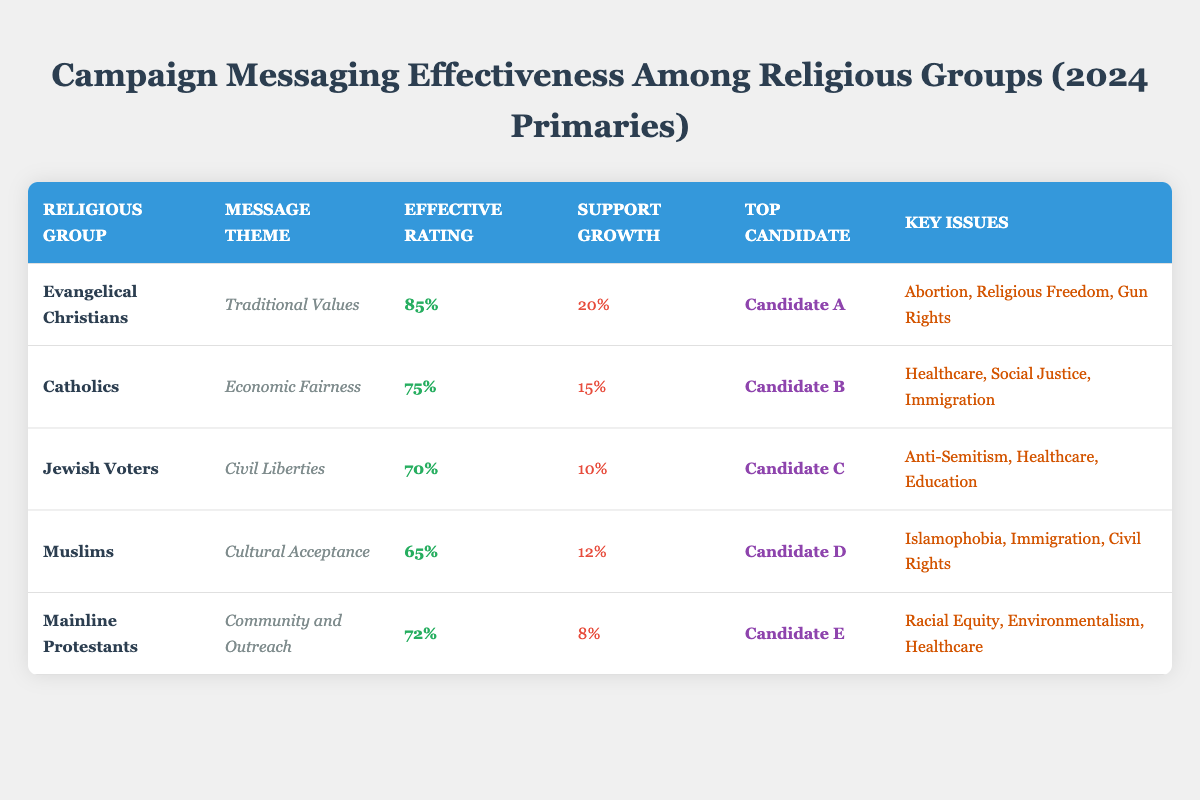What is the effective rating for Evangelical Christians? The table shows the effective rating for Evangelical Christians is 85%.
Answer: 85% Which religious group has the highest support growth percentage? By comparing the support growth percentages listed, Evangelical Christians have the highest at 20%.
Answer: Evangelical Christians Are there any religious groups with an effective rating below 70%? Yes, the groups with effective ratings below 70% are Muslims (65%) and Jewish Voters (70%).
Answer: Yes What is the average effective rating of all religious groups listed? Adding the effective ratings: 85 + 75 + 70 + 65 + 72 = 367. There are 5 groups, so the average is 367 / 5 = 73.4.
Answer: 73.4 Which candidate is favored by Catholic voters? The table states that Candidate B is the top candidate for Catholics.
Answer: Candidate B Is there a religious group for which the key issues include Immigration? Yes, both Catholics and Muslims have Immigration listed as a key issue.
Answer: Yes What is the difference in effective rating between Mainline Protestants and Muslims? The effective rating for Mainline Protestants is 72% and for Muslims it is 65%, so the difference is 72 - 65 = 7%.
Answer: 7% Which message theme is associated with the highest effective rating, and what is that rating? The message theme "Traditional Values" is associated with Evangelical Christians, who have the highest effective rating of 85%.
Answer: Traditional Values, 85% How many key issues does Candidate D (top candidate for Muslims) address? The key issues listed for Candidate D are Islamophobia, Immigration, and Civil Rights, totaling 3 key issues.
Answer: 3 